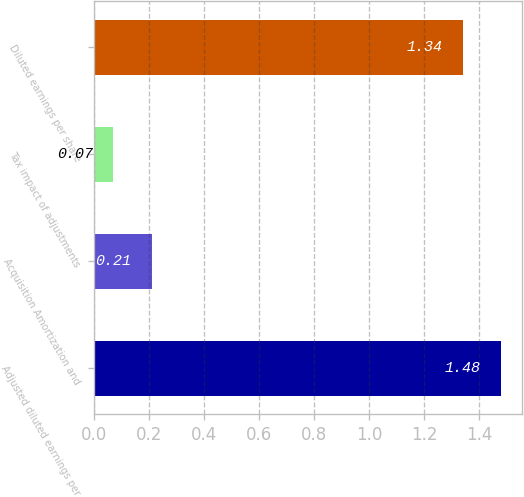<chart> <loc_0><loc_0><loc_500><loc_500><bar_chart><fcel>Adjusted diluted earnings per<fcel>Acquisition Amortization and<fcel>Tax impact of adjustments<fcel>Diluted earnings per share<nl><fcel>1.48<fcel>0.21<fcel>0.07<fcel>1.34<nl></chart> 